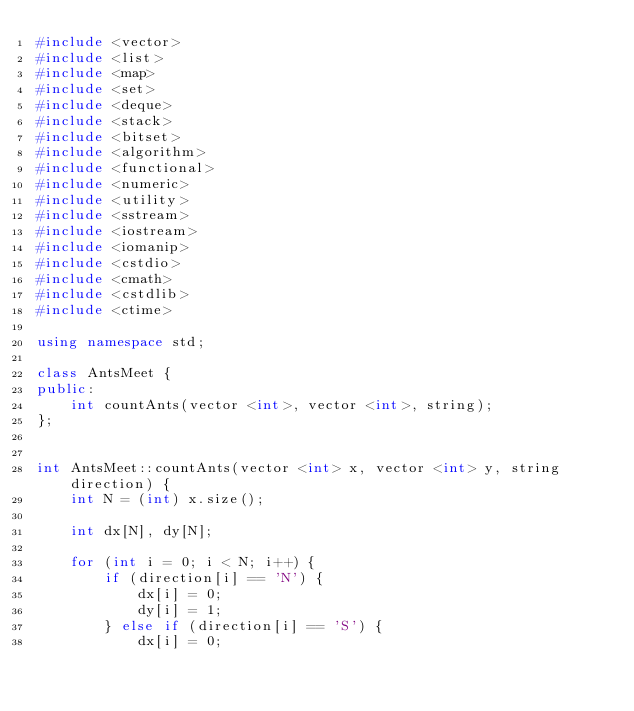Convert code to text. <code><loc_0><loc_0><loc_500><loc_500><_C++_>#include <vector>
#include <list>
#include <map>
#include <set>
#include <deque>
#include <stack>
#include <bitset>
#include <algorithm>
#include <functional>
#include <numeric>
#include <utility>
#include <sstream>
#include <iostream>
#include <iomanip>
#include <cstdio>
#include <cmath>
#include <cstdlib>
#include <ctime>

using namespace std;

class AntsMeet {
public:
	int countAnts(vector <int>, vector <int>, string);
};


int AntsMeet::countAnts(vector <int> x, vector <int> y, string direction) {
	int N = (int) x.size();

	int dx[N], dy[N];
	
	for (int i = 0; i < N; i++) {
		if (direction[i] == 'N') {
			dx[i] = 0;
			dy[i] = 1;			
		} else if (direction[i] == 'S') {
			dx[i] = 0;</code> 